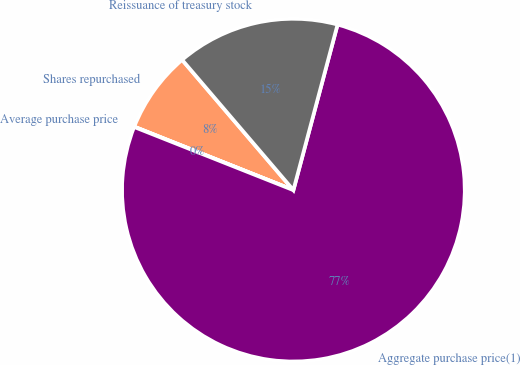Convert chart. <chart><loc_0><loc_0><loc_500><loc_500><pie_chart><fcel>Shares repurchased<fcel>Average purchase price<fcel>Aggregate purchase price(1)<fcel>Reissuance of treasury stock<nl><fcel>7.71%<fcel>0.03%<fcel>76.86%<fcel>15.4%<nl></chart> 